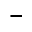Convert formula to latex. <formula><loc_0><loc_0><loc_500><loc_500>^ { - }</formula> 